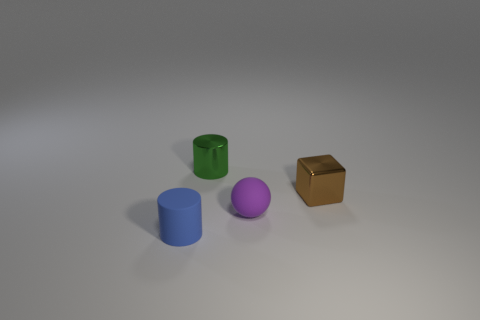Add 4 large cyan shiny balls. How many objects exist? 8 Subtract all green cylinders. How many cylinders are left? 1 Subtract all balls. How many objects are left? 3 Subtract all cyan cylinders. Subtract all brown balls. How many cylinders are left? 2 Add 4 tiny metallic objects. How many tiny metallic objects exist? 6 Subtract 0 cyan cubes. How many objects are left? 4 Subtract all tiny brown shiny things. Subtract all tiny rubber spheres. How many objects are left? 2 Add 4 brown objects. How many brown objects are left? 5 